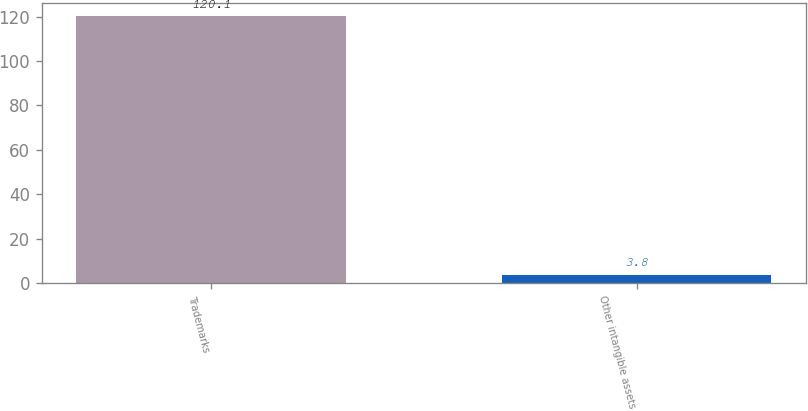Convert chart. <chart><loc_0><loc_0><loc_500><loc_500><bar_chart><fcel>Trademarks<fcel>Other intangible assets<nl><fcel>120.1<fcel>3.8<nl></chart> 